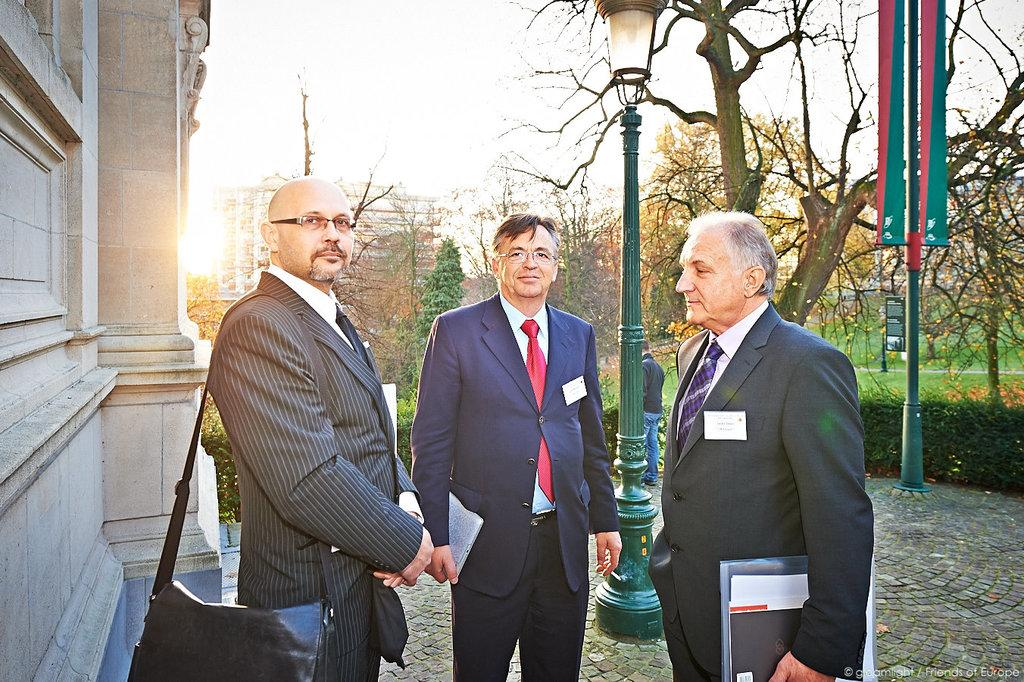What are the main subjects in the center of the image? There are persons standing in the center of the image. What can be seen in the background of the image? There are trees and buildings in the background of the image. What type of structures are present in the image? There are poles in the image. What is the ground covered with in the image? There is grass on the ground in the image. What type of haircut is the person on the left side of the image getting? There is no person getting a haircut in the image; the main subjects are standing. How does the heat affect the trees in the background of the image? The image does not provide information about the temperature or the effect of heat on the trees. 